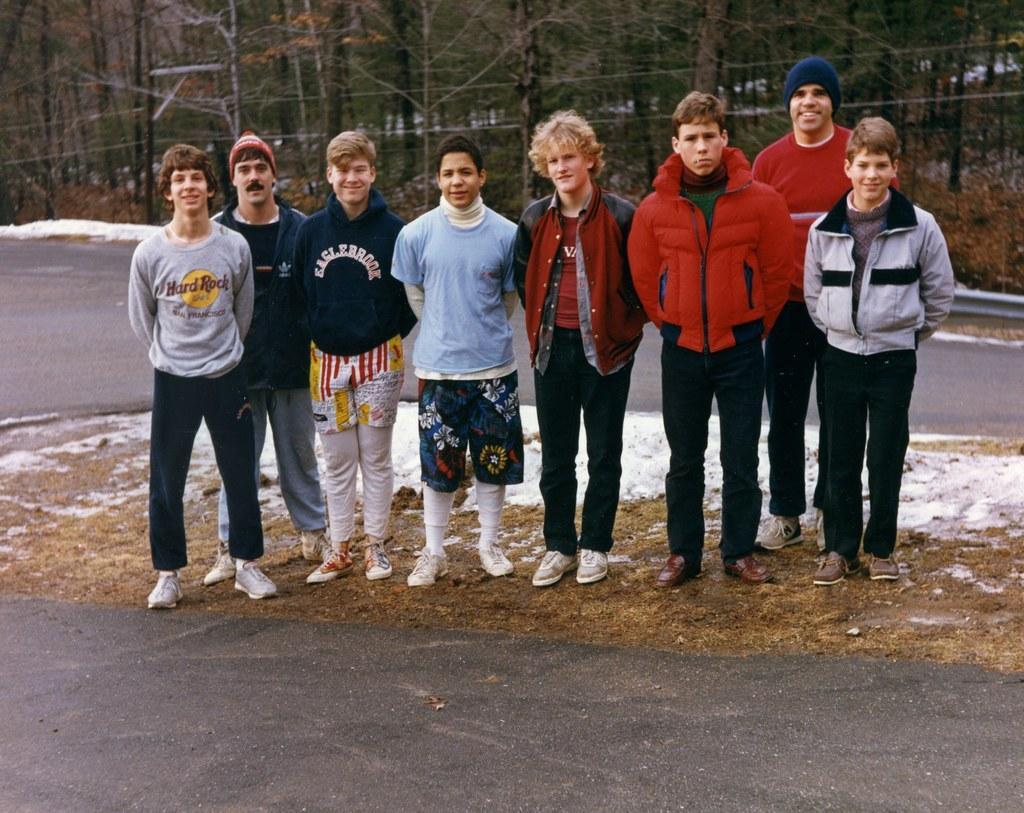In one or two sentences, can you explain what this image depicts? In this image I can see a group of men are standing and I can see most of them are wearing jackets. I can also see two of them are wearing caps. In the background I can see a road, two wires and number of trees. I can also see one more road on the bottom side of the image. 